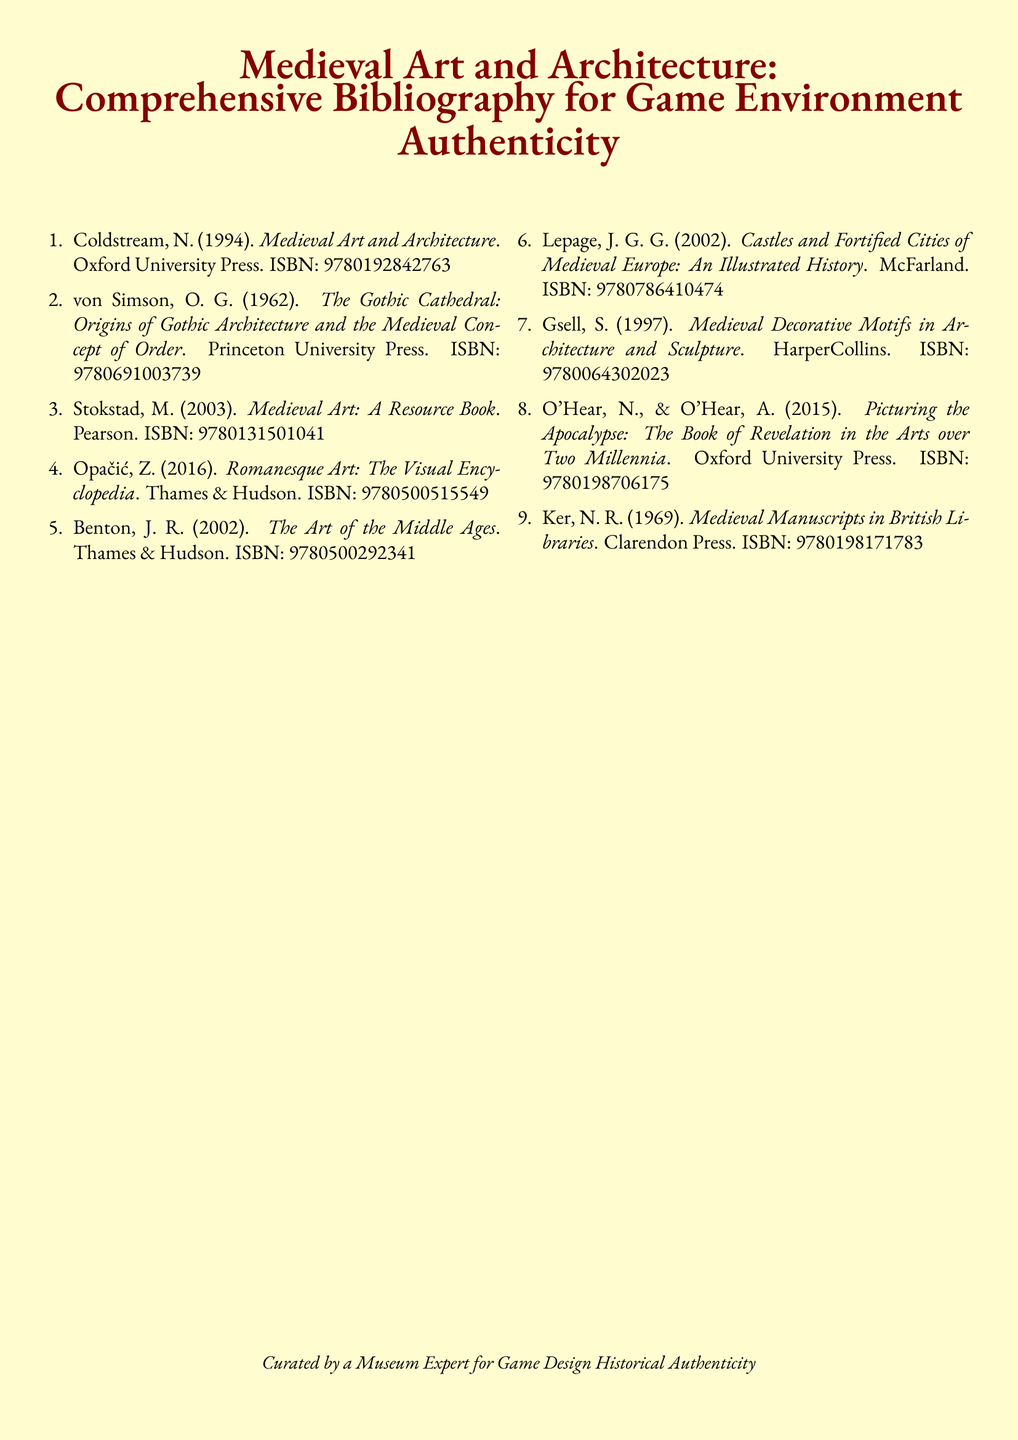What is the title of the first book listed? The first book in the bibliography is titled "Medieval Art and Architecture."
Answer: Medieval Art and Architecture Who is the author of "The Gothic Cathedral"? The author of "The Gothic Cathedral: Origins of Gothic Architecture and the Medieval Concept of Order" is O. G. von Simson.
Answer: O. G. von Simson What is the ISBN of "Romanesque Art: The Visual Encyclopedia"? The document specifies that the ISBN for "Romanesque Art: The Visual Encyclopedia" is 9780500515549.
Answer: 9780500515549 How many books are listed in the bibliography? The document contains a total of eight books listed in the bibliography.
Answer: Eight Which university published "Medieval Art: A Resource Book"? The publisher of "Medieval Art: A Resource Book" is Pearson.
Answer: Pearson What type of document is this? The document is a comprehensive bibliography designed for game environment authenticity concerning medieval art and architecture.
Answer: Bibliography What color is specified for the title sections? The color specified for the title sections is medieval red.
Answer: medieval red Who is the intended audience for the bibliography? The bibliography is curated for museum experts involved in game design historical authenticity.
Answer: museum experts 